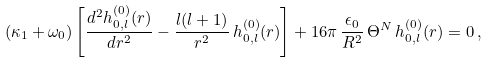Convert formula to latex. <formula><loc_0><loc_0><loc_500><loc_500>( \kappa _ { 1 } + \omega _ { 0 } ) \left [ \frac { d ^ { 2 } h ^ { ( 0 ) } _ { 0 , l } ( r ) } { d r ^ { 2 } } - \frac { l ( l + 1 ) } { r ^ { 2 } } \, h ^ { ( 0 ) } _ { 0 , l } ( r ) \right ] + 1 6 \pi \, \frac { \epsilon _ { 0 } } { R ^ { 2 } } \, \Theta ^ { N } \, h ^ { ( 0 ) } _ { 0 , l } ( r ) = 0 \, ,</formula> 